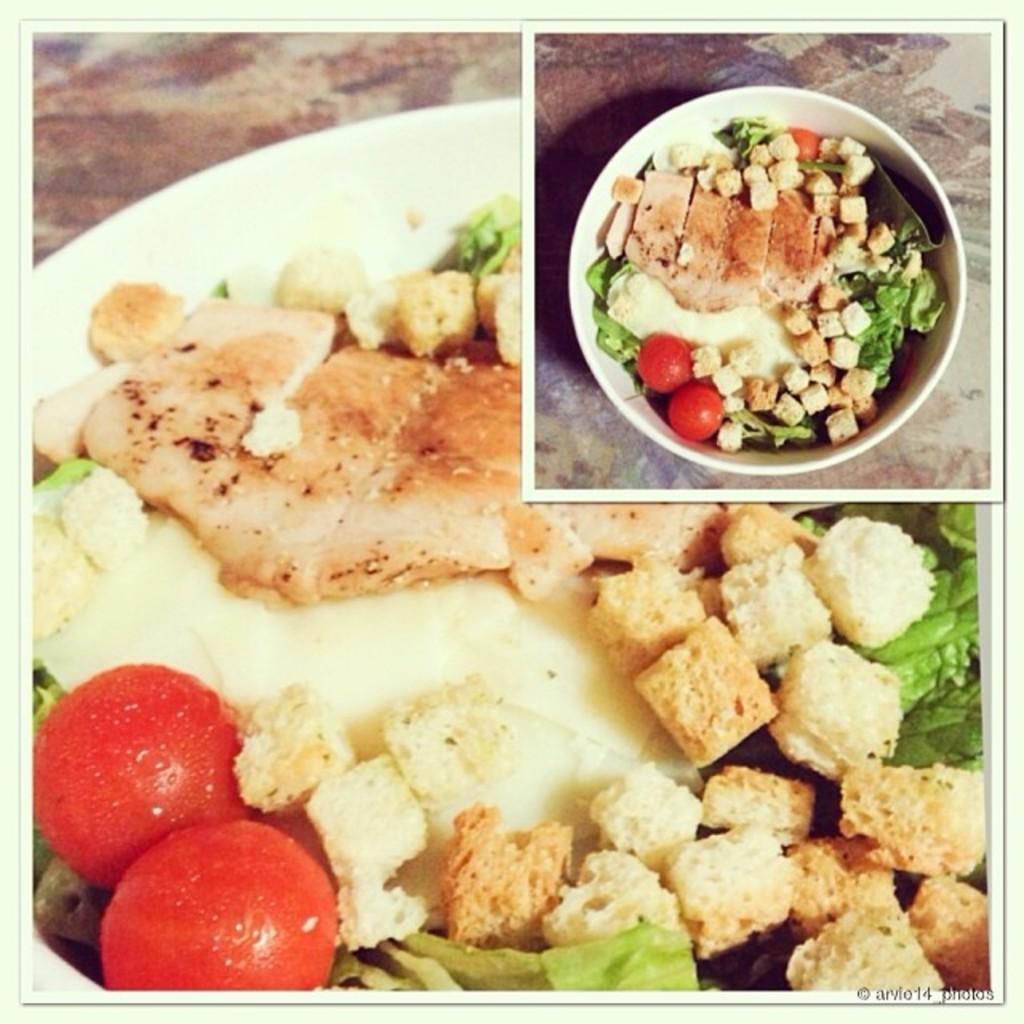How would you summarize this image in a sentence or two? In this image we can see a serving bowl which consists of meat, cheese, croutons, leaves and tomatoes. On the right top most corner of the image we can see a picture of the same serving plate. 